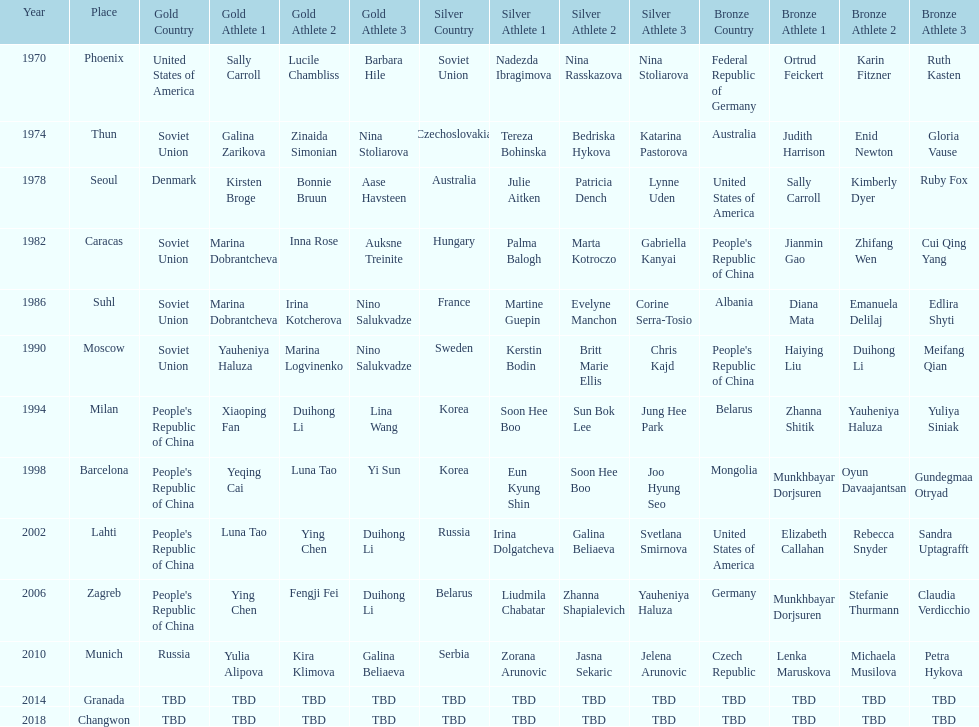How many times has germany won bronze? 2. Can you parse all the data within this table? {'header': ['Year', 'Place', 'Gold Country', 'Gold Athlete 1', 'Gold Athlete 2', 'Gold Athlete 3', 'Silver Country', 'Silver Athlete 1', 'Silver Athlete 2', 'Silver Athlete 3', 'Bronze Country', 'Bronze Athlete 1', 'Bronze Athlete 2', 'Bronze Athlete 3'], 'rows': [['1970', 'Phoenix', 'United States of America', 'Sally Carroll', 'Lucile Chambliss', 'Barbara Hile', 'Soviet Union', 'Nadezda Ibragimova', 'Nina Rasskazova', 'Nina Stoliarova', 'Federal Republic of Germany', 'Ortrud Feickert', 'Karin Fitzner', 'Ruth Kasten'], ['1974', 'Thun', 'Soviet Union', 'Galina Zarikova', 'Zinaida Simonian', 'Nina Stoliarova', 'Czechoslovakia', 'Tereza Bohinska', 'Bedriska Hykova', 'Katarina Pastorova', 'Australia', 'Judith Harrison', 'Enid Newton', 'Gloria Vause'], ['1978', 'Seoul', 'Denmark', 'Kirsten Broge', 'Bonnie Bruun', 'Aase Havsteen', 'Australia', 'Julie Aitken', 'Patricia Dench', 'Lynne Uden', 'United States of America', 'Sally Carroll', 'Kimberly Dyer', 'Ruby Fox'], ['1982', 'Caracas', 'Soviet Union', 'Marina Dobrantcheva', 'Inna Rose', 'Auksne Treinite', 'Hungary', 'Palma Balogh', 'Marta Kotroczo', 'Gabriella Kanyai', "People's Republic of China", 'Jianmin Gao', 'Zhifang Wen', 'Cui Qing Yang'], ['1986', 'Suhl', 'Soviet Union', 'Marina Dobrantcheva', 'Irina Kotcherova', 'Nino Salukvadze', 'France', 'Martine Guepin', 'Evelyne Manchon', 'Corine Serra-Tosio', 'Albania', 'Diana Mata', 'Emanuela Delilaj', 'Edlira Shyti'], ['1990', 'Moscow', 'Soviet Union', 'Yauheniya Haluza', 'Marina Logvinenko', 'Nino Salukvadze', 'Sweden', 'Kerstin Bodin', 'Britt Marie Ellis', 'Chris Kajd', "People's Republic of China", 'Haiying Liu', 'Duihong Li', 'Meifang Qian'], ['1994', 'Milan', "People's Republic of China", 'Xiaoping Fan', 'Duihong Li', 'Lina Wang', 'Korea', 'Soon Hee Boo', 'Sun Bok Lee', 'Jung Hee Park', 'Belarus', 'Zhanna Shitik', 'Yauheniya Haluza', 'Yuliya Siniak'], ['1998', 'Barcelona', "People's Republic of China", 'Yeqing Cai', 'Luna Tao', 'Yi Sun', 'Korea', 'Eun Kyung Shin', 'Soon Hee Boo', 'Joo Hyung Seo', 'Mongolia', 'Munkhbayar Dorjsuren', 'Oyun Davaajantsan', 'Gundegmaa Otryad'], ['2002', 'Lahti', "People's Republic of China", 'Luna Tao', 'Ying Chen', 'Duihong Li', 'Russia', 'Irina Dolgatcheva', 'Galina Beliaeva', 'Svetlana Smirnova', 'United States of America', 'Elizabeth Callahan', 'Rebecca Snyder', 'Sandra Uptagrafft'], ['2006', 'Zagreb', "People's Republic of China", 'Ying Chen', 'Fengji Fei', 'Duihong Li', 'Belarus', 'Liudmila Chabatar', 'Zhanna Shapialevich', 'Yauheniya Haluza', 'Germany', 'Munkhbayar Dorjsuren', 'Stefanie Thurmann', 'Claudia Verdicchio'], ['2010', 'Munich', 'Russia', 'Yulia Alipova', 'Kira Klimova', 'Galina Beliaeva', 'Serbia', 'Zorana Arunovic', 'Jasna Sekaric', 'Jelena Arunovic', 'Czech Republic', 'Lenka Maruskova', 'Michaela Musilova', 'Petra Hykova'], ['2014', 'Granada', 'TBD', 'TBD', 'TBD', 'TBD', 'TBD', 'TBD', 'TBD', 'TBD', 'TBD', 'TBD', 'TBD', 'TBD'], ['2018', 'Changwon', 'TBD', 'TBD', 'TBD', 'TBD', 'TBD', 'TBD', 'TBD', 'TBD', 'TBD', 'TBD', 'TBD', 'TBD']]} 